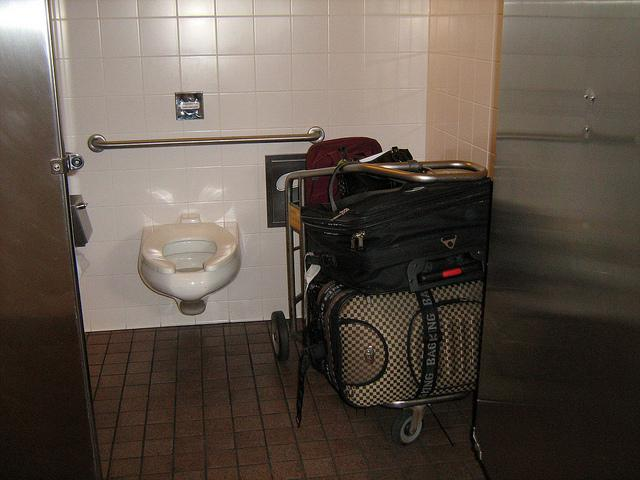Where is this bathroom likely to be found in? Please explain your reasoning. airport. The bathroom has luggage in it. 